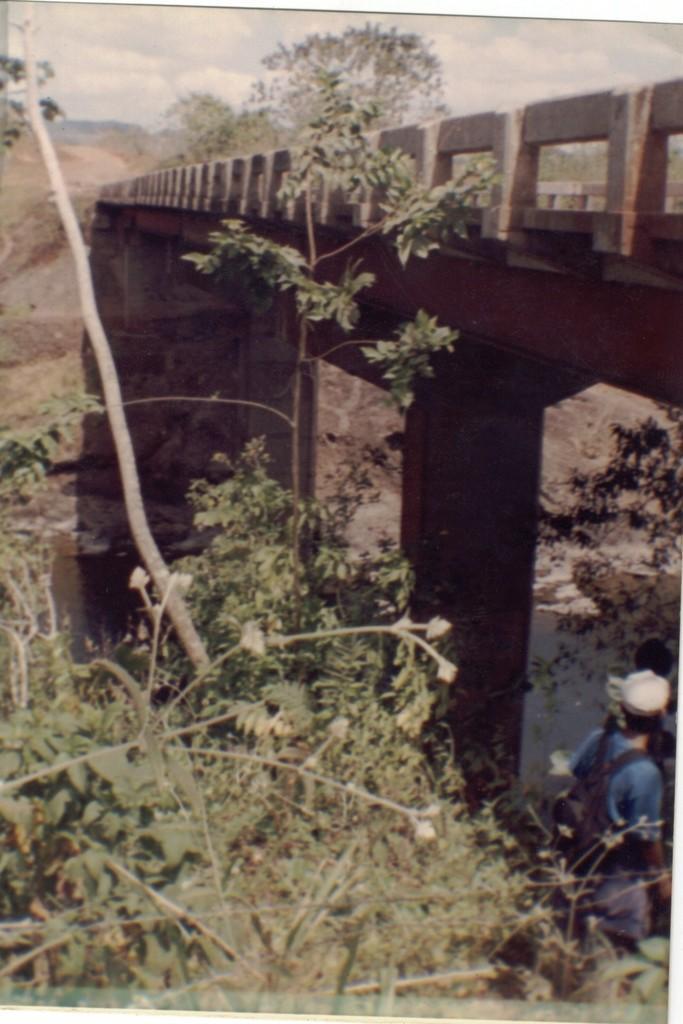Can you describe this image briefly? This is a photo. In the center of the image we can see bridgewater. At the bottom of the image we can see some plants and a person is standing and wearing cap, bag. At the top of the image we can see trees, ground and clouds are present in the sky. 